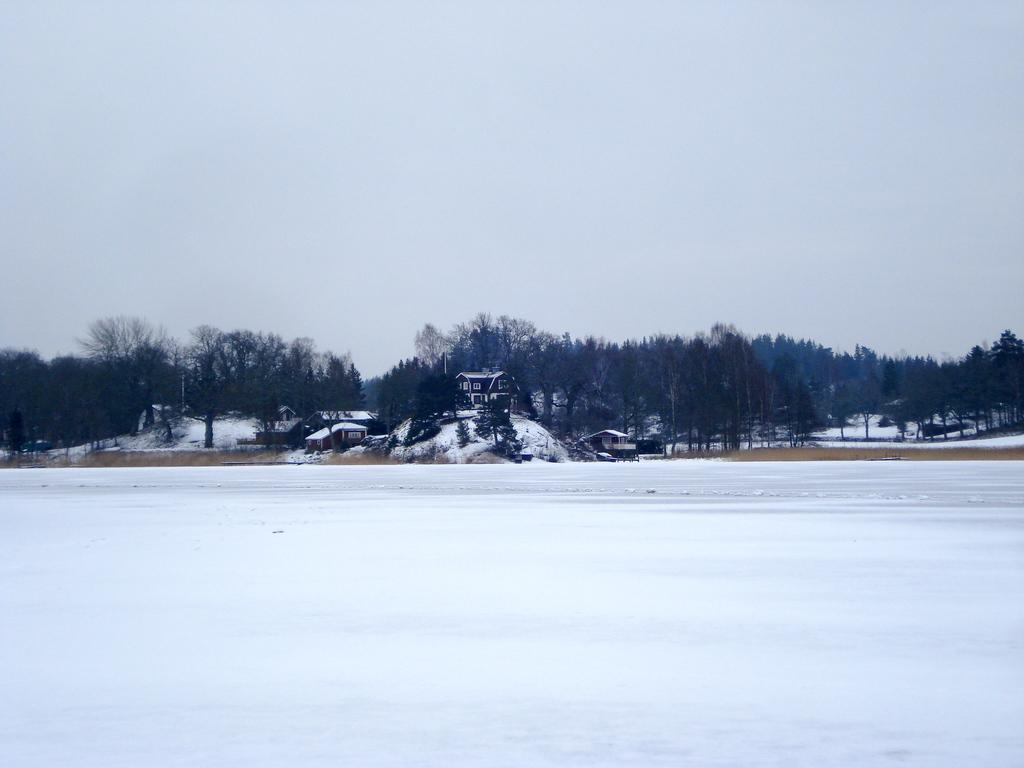What type of structures can be seen in the image? There are houses in the image. What other natural elements are present in the image? There are trees in the image. What is the weather condition in the image? There is snow visible in the image, indicating a cold or wintery condition. What can be seen in the background of the image? The sky is visible in the background of the image. Can you tell me how many grapes are hanging from the trees in the image? There are no grapes present in the image; the trees are covered in snow. 